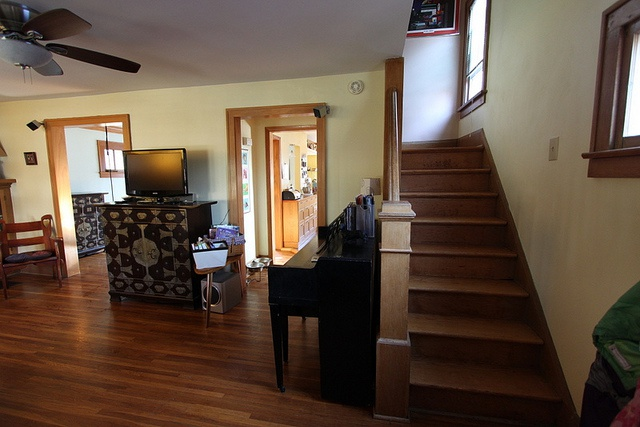Describe the objects in this image and their specific colors. I can see tv in gray, black, olive, and maroon tones and chair in gray, maroon, black, and tan tones in this image. 